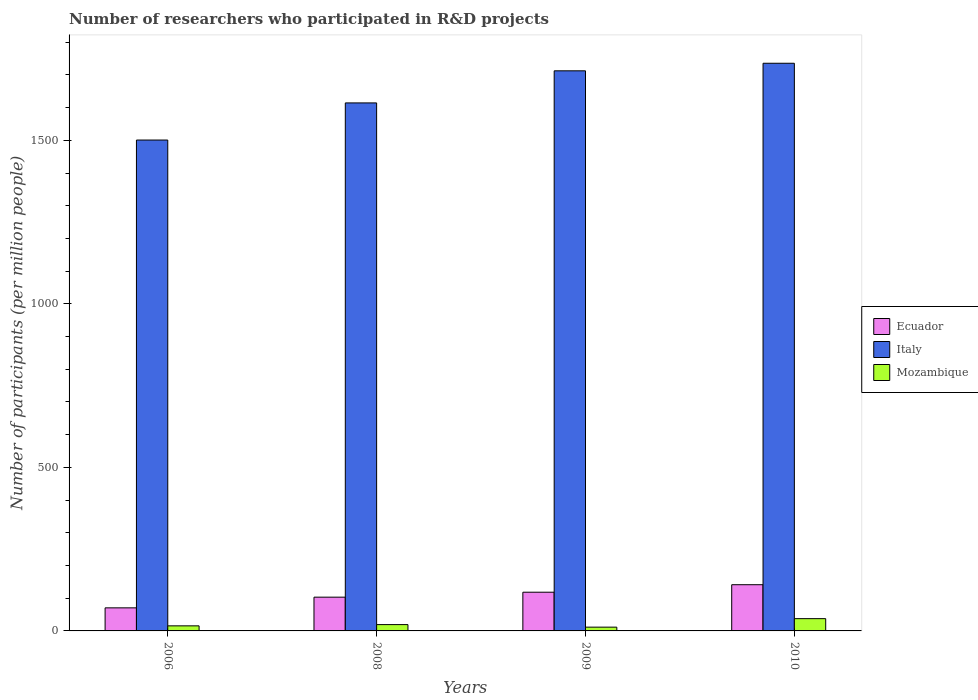How many different coloured bars are there?
Make the answer very short. 3. Are the number of bars on each tick of the X-axis equal?
Your answer should be very brief. Yes. How many bars are there on the 2nd tick from the right?
Offer a terse response. 3. In how many cases, is the number of bars for a given year not equal to the number of legend labels?
Your answer should be very brief. 0. What is the number of researchers who participated in R&D projects in Ecuador in 2008?
Make the answer very short. 103.23. Across all years, what is the maximum number of researchers who participated in R&D projects in Ecuador?
Provide a succinct answer. 141.3. Across all years, what is the minimum number of researchers who participated in R&D projects in Italy?
Your answer should be very brief. 1500.88. In which year was the number of researchers who participated in R&D projects in Ecuador maximum?
Give a very brief answer. 2010. What is the total number of researchers who participated in R&D projects in Italy in the graph?
Give a very brief answer. 6563.5. What is the difference between the number of researchers who participated in R&D projects in Mozambique in 2006 and that in 2008?
Your answer should be very brief. -3.8. What is the difference between the number of researchers who participated in R&D projects in Mozambique in 2008 and the number of researchers who participated in R&D projects in Italy in 2010?
Provide a succinct answer. -1716.36. What is the average number of researchers who participated in R&D projects in Ecuador per year?
Offer a terse response. 108.35. In the year 2010, what is the difference between the number of researchers who participated in R&D projects in Ecuador and number of researchers who participated in R&D projects in Mozambique?
Your response must be concise. 103.79. What is the ratio of the number of researchers who participated in R&D projects in Mozambique in 2006 to that in 2008?
Give a very brief answer. 0.8. Is the difference between the number of researchers who participated in R&D projects in Ecuador in 2009 and 2010 greater than the difference between the number of researchers who participated in R&D projects in Mozambique in 2009 and 2010?
Ensure brevity in your answer.  Yes. What is the difference between the highest and the second highest number of researchers who participated in R&D projects in Italy?
Keep it short and to the point. 23.11. What is the difference between the highest and the lowest number of researchers who participated in R&D projects in Ecuador?
Provide a short and direct response. 70.78. What does the 1st bar from the left in 2006 represents?
Your answer should be very brief. Ecuador. What does the 3rd bar from the right in 2009 represents?
Give a very brief answer. Ecuador. Is it the case that in every year, the sum of the number of researchers who participated in R&D projects in Mozambique and number of researchers who participated in R&D projects in Italy is greater than the number of researchers who participated in R&D projects in Ecuador?
Give a very brief answer. Yes. What is the difference between two consecutive major ticks on the Y-axis?
Provide a succinct answer. 500. How are the legend labels stacked?
Your answer should be compact. Vertical. What is the title of the graph?
Give a very brief answer. Number of researchers who participated in R&D projects. What is the label or title of the X-axis?
Provide a succinct answer. Years. What is the label or title of the Y-axis?
Offer a terse response. Number of participants (per million people). What is the Number of participants (per million people) of Ecuador in 2006?
Keep it short and to the point. 70.52. What is the Number of participants (per million people) in Italy in 2006?
Offer a terse response. 1500.88. What is the Number of participants (per million people) in Mozambique in 2006?
Give a very brief answer. 15.5. What is the Number of participants (per million people) of Ecuador in 2008?
Make the answer very short. 103.23. What is the Number of participants (per million people) of Italy in 2008?
Provide a short and direct response. 1614.42. What is the Number of participants (per million people) in Mozambique in 2008?
Make the answer very short. 19.3. What is the Number of participants (per million people) in Ecuador in 2009?
Your answer should be compact. 118.35. What is the Number of participants (per million people) of Italy in 2009?
Your answer should be compact. 1712.54. What is the Number of participants (per million people) of Mozambique in 2009?
Provide a short and direct response. 11.53. What is the Number of participants (per million people) of Ecuador in 2010?
Make the answer very short. 141.3. What is the Number of participants (per million people) of Italy in 2010?
Offer a terse response. 1735.66. What is the Number of participants (per million people) in Mozambique in 2010?
Make the answer very short. 37.51. Across all years, what is the maximum Number of participants (per million people) in Ecuador?
Offer a very short reply. 141.3. Across all years, what is the maximum Number of participants (per million people) of Italy?
Offer a terse response. 1735.66. Across all years, what is the maximum Number of participants (per million people) of Mozambique?
Offer a very short reply. 37.51. Across all years, what is the minimum Number of participants (per million people) in Ecuador?
Your answer should be compact. 70.52. Across all years, what is the minimum Number of participants (per million people) of Italy?
Offer a terse response. 1500.88. Across all years, what is the minimum Number of participants (per million people) of Mozambique?
Keep it short and to the point. 11.53. What is the total Number of participants (per million people) of Ecuador in the graph?
Give a very brief answer. 433.4. What is the total Number of participants (per million people) of Italy in the graph?
Your response must be concise. 6563.5. What is the total Number of participants (per million people) in Mozambique in the graph?
Your answer should be very brief. 83.84. What is the difference between the Number of participants (per million people) in Ecuador in 2006 and that in 2008?
Make the answer very short. -32.71. What is the difference between the Number of participants (per million people) of Italy in 2006 and that in 2008?
Give a very brief answer. -113.54. What is the difference between the Number of participants (per million people) in Mozambique in 2006 and that in 2008?
Your answer should be compact. -3.8. What is the difference between the Number of participants (per million people) in Ecuador in 2006 and that in 2009?
Offer a terse response. -47.83. What is the difference between the Number of participants (per million people) of Italy in 2006 and that in 2009?
Make the answer very short. -211.66. What is the difference between the Number of participants (per million people) of Mozambique in 2006 and that in 2009?
Ensure brevity in your answer.  3.98. What is the difference between the Number of participants (per million people) in Ecuador in 2006 and that in 2010?
Your answer should be compact. -70.78. What is the difference between the Number of participants (per million people) of Italy in 2006 and that in 2010?
Provide a short and direct response. -234.78. What is the difference between the Number of participants (per million people) of Mozambique in 2006 and that in 2010?
Provide a succinct answer. -22.01. What is the difference between the Number of participants (per million people) of Ecuador in 2008 and that in 2009?
Give a very brief answer. -15.12. What is the difference between the Number of participants (per million people) in Italy in 2008 and that in 2009?
Provide a succinct answer. -98.12. What is the difference between the Number of participants (per million people) of Mozambique in 2008 and that in 2009?
Give a very brief answer. 7.77. What is the difference between the Number of participants (per million people) of Ecuador in 2008 and that in 2010?
Offer a very short reply. -38.07. What is the difference between the Number of participants (per million people) in Italy in 2008 and that in 2010?
Keep it short and to the point. -121.23. What is the difference between the Number of participants (per million people) in Mozambique in 2008 and that in 2010?
Offer a very short reply. -18.21. What is the difference between the Number of participants (per million people) in Ecuador in 2009 and that in 2010?
Offer a terse response. -22.95. What is the difference between the Number of participants (per million people) of Italy in 2009 and that in 2010?
Give a very brief answer. -23.11. What is the difference between the Number of participants (per million people) in Mozambique in 2009 and that in 2010?
Make the answer very short. -25.99. What is the difference between the Number of participants (per million people) of Ecuador in 2006 and the Number of participants (per million people) of Italy in 2008?
Give a very brief answer. -1543.9. What is the difference between the Number of participants (per million people) of Ecuador in 2006 and the Number of participants (per million people) of Mozambique in 2008?
Offer a terse response. 51.22. What is the difference between the Number of participants (per million people) of Italy in 2006 and the Number of participants (per million people) of Mozambique in 2008?
Keep it short and to the point. 1481.58. What is the difference between the Number of participants (per million people) of Ecuador in 2006 and the Number of participants (per million people) of Italy in 2009?
Your answer should be very brief. -1642.02. What is the difference between the Number of participants (per million people) in Ecuador in 2006 and the Number of participants (per million people) in Mozambique in 2009?
Your answer should be compact. 58.99. What is the difference between the Number of participants (per million people) in Italy in 2006 and the Number of participants (per million people) in Mozambique in 2009?
Make the answer very short. 1489.35. What is the difference between the Number of participants (per million people) of Ecuador in 2006 and the Number of participants (per million people) of Italy in 2010?
Your answer should be compact. -1665.14. What is the difference between the Number of participants (per million people) of Ecuador in 2006 and the Number of participants (per million people) of Mozambique in 2010?
Your answer should be very brief. 33.01. What is the difference between the Number of participants (per million people) of Italy in 2006 and the Number of participants (per million people) of Mozambique in 2010?
Your answer should be compact. 1463.37. What is the difference between the Number of participants (per million people) in Ecuador in 2008 and the Number of participants (per million people) in Italy in 2009?
Make the answer very short. -1609.31. What is the difference between the Number of participants (per million people) of Ecuador in 2008 and the Number of participants (per million people) of Mozambique in 2009?
Offer a very short reply. 91.71. What is the difference between the Number of participants (per million people) of Italy in 2008 and the Number of participants (per million people) of Mozambique in 2009?
Ensure brevity in your answer.  1602.9. What is the difference between the Number of participants (per million people) of Ecuador in 2008 and the Number of participants (per million people) of Italy in 2010?
Provide a short and direct response. -1632.42. What is the difference between the Number of participants (per million people) in Ecuador in 2008 and the Number of participants (per million people) in Mozambique in 2010?
Offer a terse response. 65.72. What is the difference between the Number of participants (per million people) in Italy in 2008 and the Number of participants (per million people) in Mozambique in 2010?
Keep it short and to the point. 1576.91. What is the difference between the Number of participants (per million people) in Ecuador in 2009 and the Number of participants (per million people) in Italy in 2010?
Keep it short and to the point. -1617.31. What is the difference between the Number of participants (per million people) of Ecuador in 2009 and the Number of participants (per million people) of Mozambique in 2010?
Ensure brevity in your answer.  80.84. What is the difference between the Number of participants (per million people) of Italy in 2009 and the Number of participants (per million people) of Mozambique in 2010?
Make the answer very short. 1675.03. What is the average Number of participants (per million people) in Ecuador per year?
Your response must be concise. 108.35. What is the average Number of participants (per million people) of Italy per year?
Provide a short and direct response. 1640.88. What is the average Number of participants (per million people) in Mozambique per year?
Make the answer very short. 20.96. In the year 2006, what is the difference between the Number of participants (per million people) in Ecuador and Number of participants (per million people) in Italy?
Provide a succinct answer. -1430.36. In the year 2006, what is the difference between the Number of participants (per million people) of Ecuador and Number of participants (per million people) of Mozambique?
Give a very brief answer. 55.02. In the year 2006, what is the difference between the Number of participants (per million people) in Italy and Number of participants (per million people) in Mozambique?
Your answer should be compact. 1485.38. In the year 2008, what is the difference between the Number of participants (per million people) of Ecuador and Number of participants (per million people) of Italy?
Your response must be concise. -1511.19. In the year 2008, what is the difference between the Number of participants (per million people) of Ecuador and Number of participants (per million people) of Mozambique?
Offer a very short reply. 83.93. In the year 2008, what is the difference between the Number of participants (per million people) of Italy and Number of participants (per million people) of Mozambique?
Your answer should be compact. 1595.12. In the year 2009, what is the difference between the Number of participants (per million people) in Ecuador and Number of participants (per million people) in Italy?
Your answer should be very brief. -1594.19. In the year 2009, what is the difference between the Number of participants (per million people) in Ecuador and Number of participants (per million people) in Mozambique?
Your answer should be compact. 106.82. In the year 2009, what is the difference between the Number of participants (per million people) of Italy and Number of participants (per million people) of Mozambique?
Keep it short and to the point. 1701.02. In the year 2010, what is the difference between the Number of participants (per million people) of Ecuador and Number of participants (per million people) of Italy?
Provide a succinct answer. -1594.36. In the year 2010, what is the difference between the Number of participants (per million people) in Ecuador and Number of participants (per million people) in Mozambique?
Your response must be concise. 103.79. In the year 2010, what is the difference between the Number of participants (per million people) in Italy and Number of participants (per million people) in Mozambique?
Your response must be concise. 1698.14. What is the ratio of the Number of participants (per million people) of Ecuador in 2006 to that in 2008?
Offer a terse response. 0.68. What is the ratio of the Number of participants (per million people) of Italy in 2006 to that in 2008?
Keep it short and to the point. 0.93. What is the ratio of the Number of participants (per million people) of Mozambique in 2006 to that in 2008?
Keep it short and to the point. 0.8. What is the ratio of the Number of participants (per million people) in Ecuador in 2006 to that in 2009?
Offer a very short reply. 0.6. What is the ratio of the Number of participants (per million people) of Italy in 2006 to that in 2009?
Your answer should be compact. 0.88. What is the ratio of the Number of participants (per million people) in Mozambique in 2006 to that in 2009?
Offer a terse response. 1.34. What is the ratio of the Number of participants (per million people) in Ecuador in 2006 to that in 2010?
Offer a terse response. 0.5. What is the ratio of the Number of participants (per million people) of Italy in 2006 to that in 2010?
Your answer should be compact. 0.86. What is the ratio of the Number of participants (per million people) of Mozambique in 2006 to that in 2010?
Keep it short and to the point. 0.41. What is the ratio of the Number of participants (per million people) in Ecuador in 2008 to that in 2009?
Ensure brevity in your answer.  0.87. What is the ratio of the Number of participants (per million people) of Italy in 2008 to that in 2009?
Provide a succinct answer. 0.94. What is the ratio of the Number of participants (per million people) of Mozambique in 2008 to that in 2009?
Your answer should be very brief. 1.67. What is the ratio of the Number of participants (per million people) of Ecuador in 2008 to that in 2010?
Keep it short and to the point. 0.73. What is the ratio of the Number of participants (per million people) in Italy in 2008 to that in 2010?
Provide a short and direct response. 0.93. What is the ratio of the Number of participants (per million people) in Mozambique in 2008 to that in 2010?
Your answer should be very brief. 0.51. What is the ratio of the Number of participants (per million people) in Ecuador in 2009 to that in 2010?
Provide a short and direct response. 0.84. What is the ratio of the Number of participants (per million people) in Italy in 2009 to that in 2010?
Offer a terse response. 0.99. What is the ratio of the Number of participants (per million people) in Mozambique in 2009 to that in 2010?
Provide a succinct answer. 0.31. What is the difference between the highest and the second highest Number of participants (per million people) in Ecuador?
Give a very brief answer. 22.95. What is the difference between the highest and the second highest Number of participants (per million people) in Italy?
Make the answer very short. 23.11. What is the difference between the highest and the second highest Number of participants (per million people) in Mozambique?
Ensure brevity in your answer.  18.21. What is the difference between the highest and the lowest Number of participants (per million people) of Ecuador?
Ensure brevity in your answer.  70.78. What is the difference between the highest and the lowest Number of participants (per million people) in Italy?
Provide a succinct answer. 234.78. What is the difference between the highest and the lowest Number of participants (per million people) of Mozambique?
Offer a terse response. 25.99. 